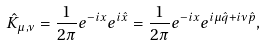<formula> <loc_0><loc_0><loc_500><loc_500>\hat { K } _ { \mu , \nu } = \frac { 1 } { 2 \pi } e ^ { - i x } e ^ { i \hat { x } } = \frac { 1 } { 2 \pi } e ^ { - i x } e ^ { i \mu { \hat { q } } + i \nu { \hat { p } } } ,</formula> 